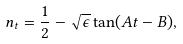<formula> <loc_0><loc_0><loc_500><loc_500>n _ { t } = { \frac { 1 } { 2 } } - \sqrt { \epsilon } \tan ( A t - B ) ,</formula> 